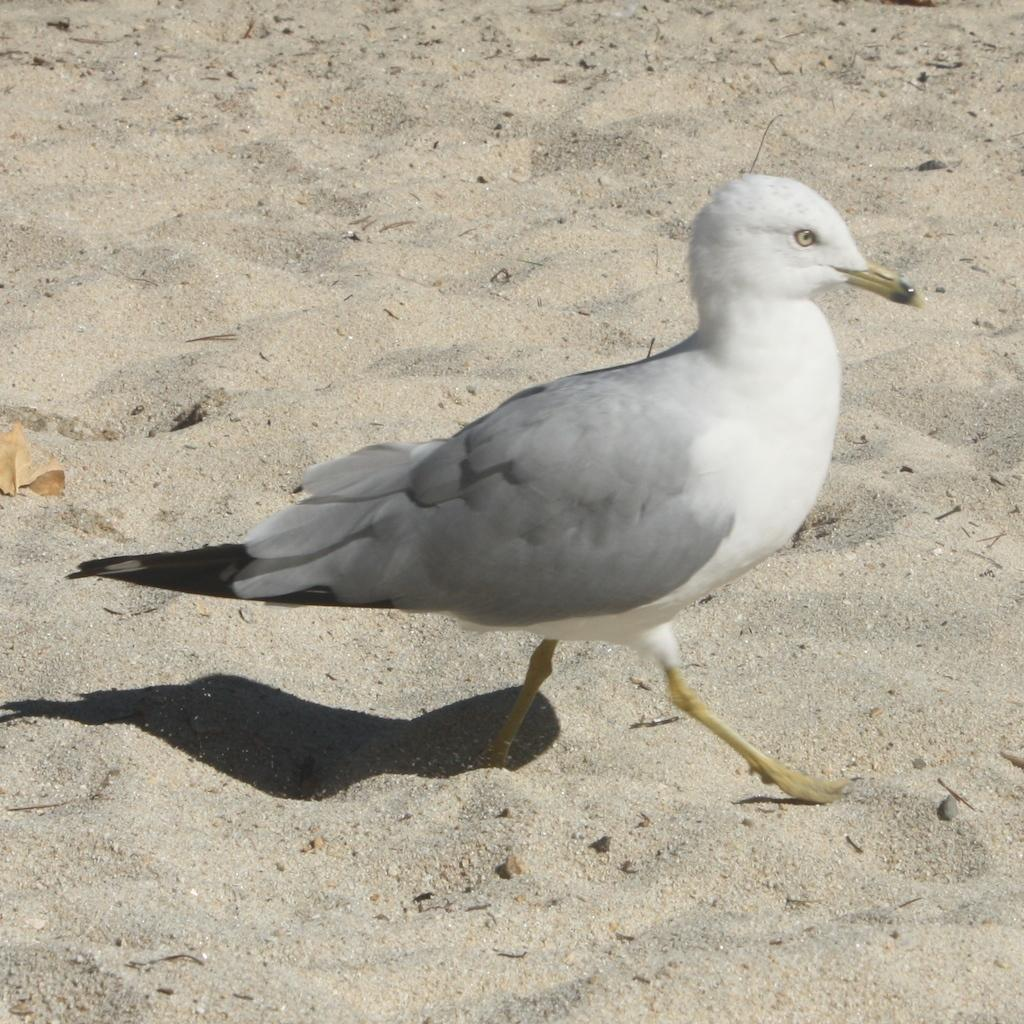What type of terrain is visible in the image? There is sand in the image. What can be seen in the image that indicates the presence of light? There is a shadow in the image. What kind of bird is present in the image? There is a white and grey colored bird in the image. How many oranges are present in the image? There are no oranges present in the image. What type of tree can be seen in the image? There is no tree present in the image. 